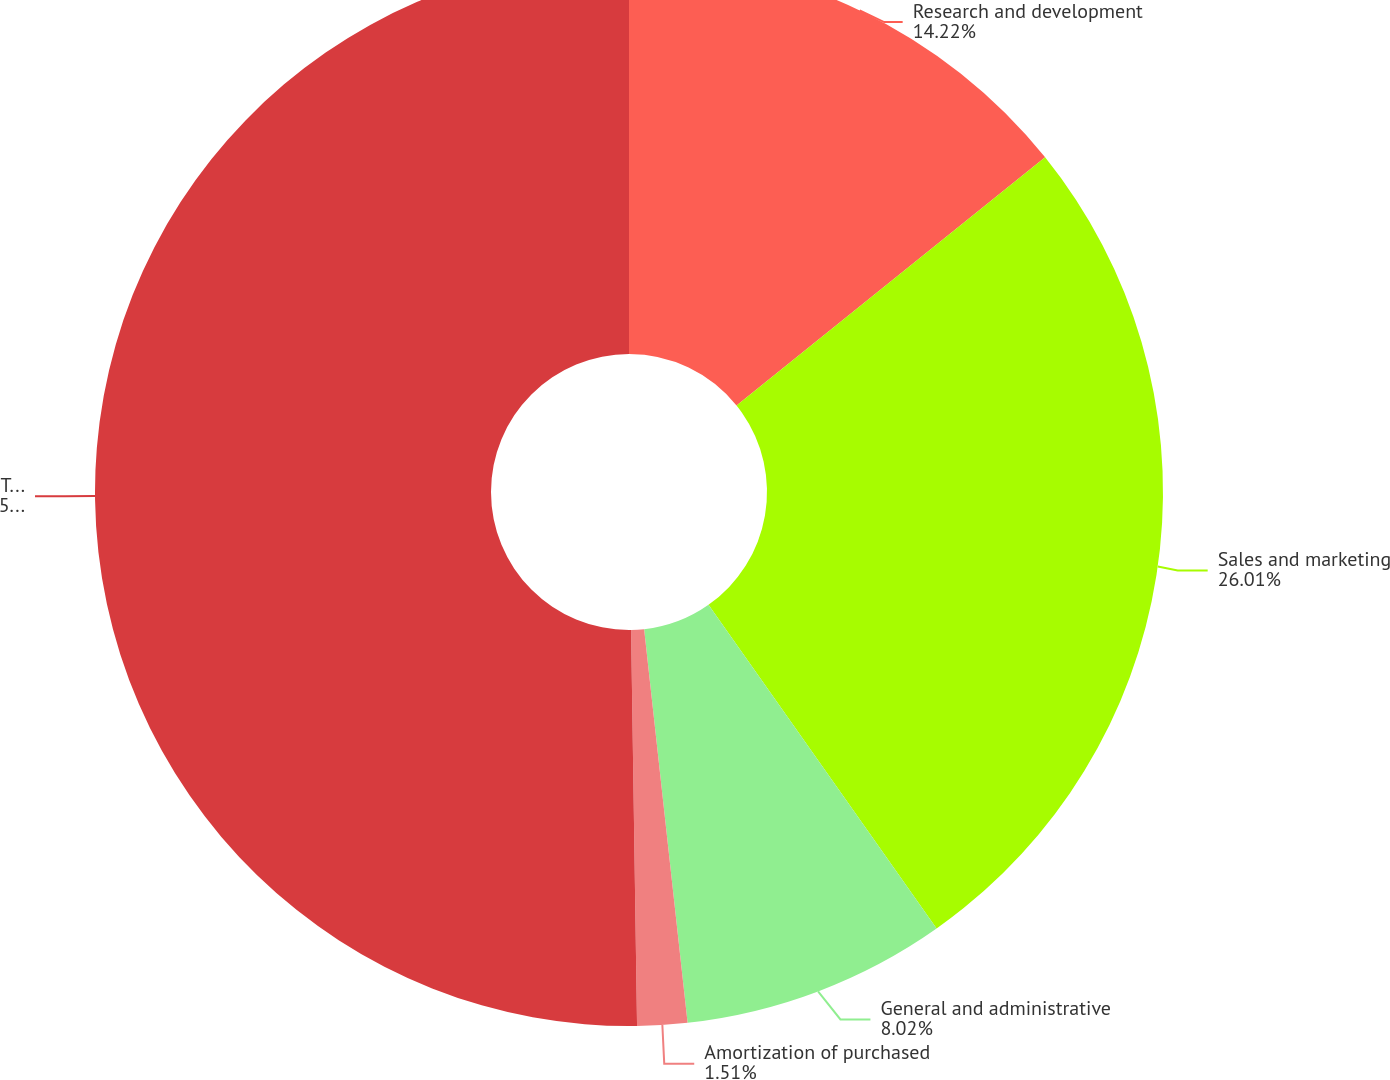Convert chart to OTSL. <chart><loc_0><loc_0><loc_500><loc_500><pie_chart><fcel>Research and development<fcel>Sales and marketing<fcel>General and administrative<fcel>Amortization of purchased<fcel>Total operating expenses<nl><fcel>14.22%<fcel>26.01%<fcel>8.02%<fcel>1.51%<fcel>50.24%<nl></chart> 